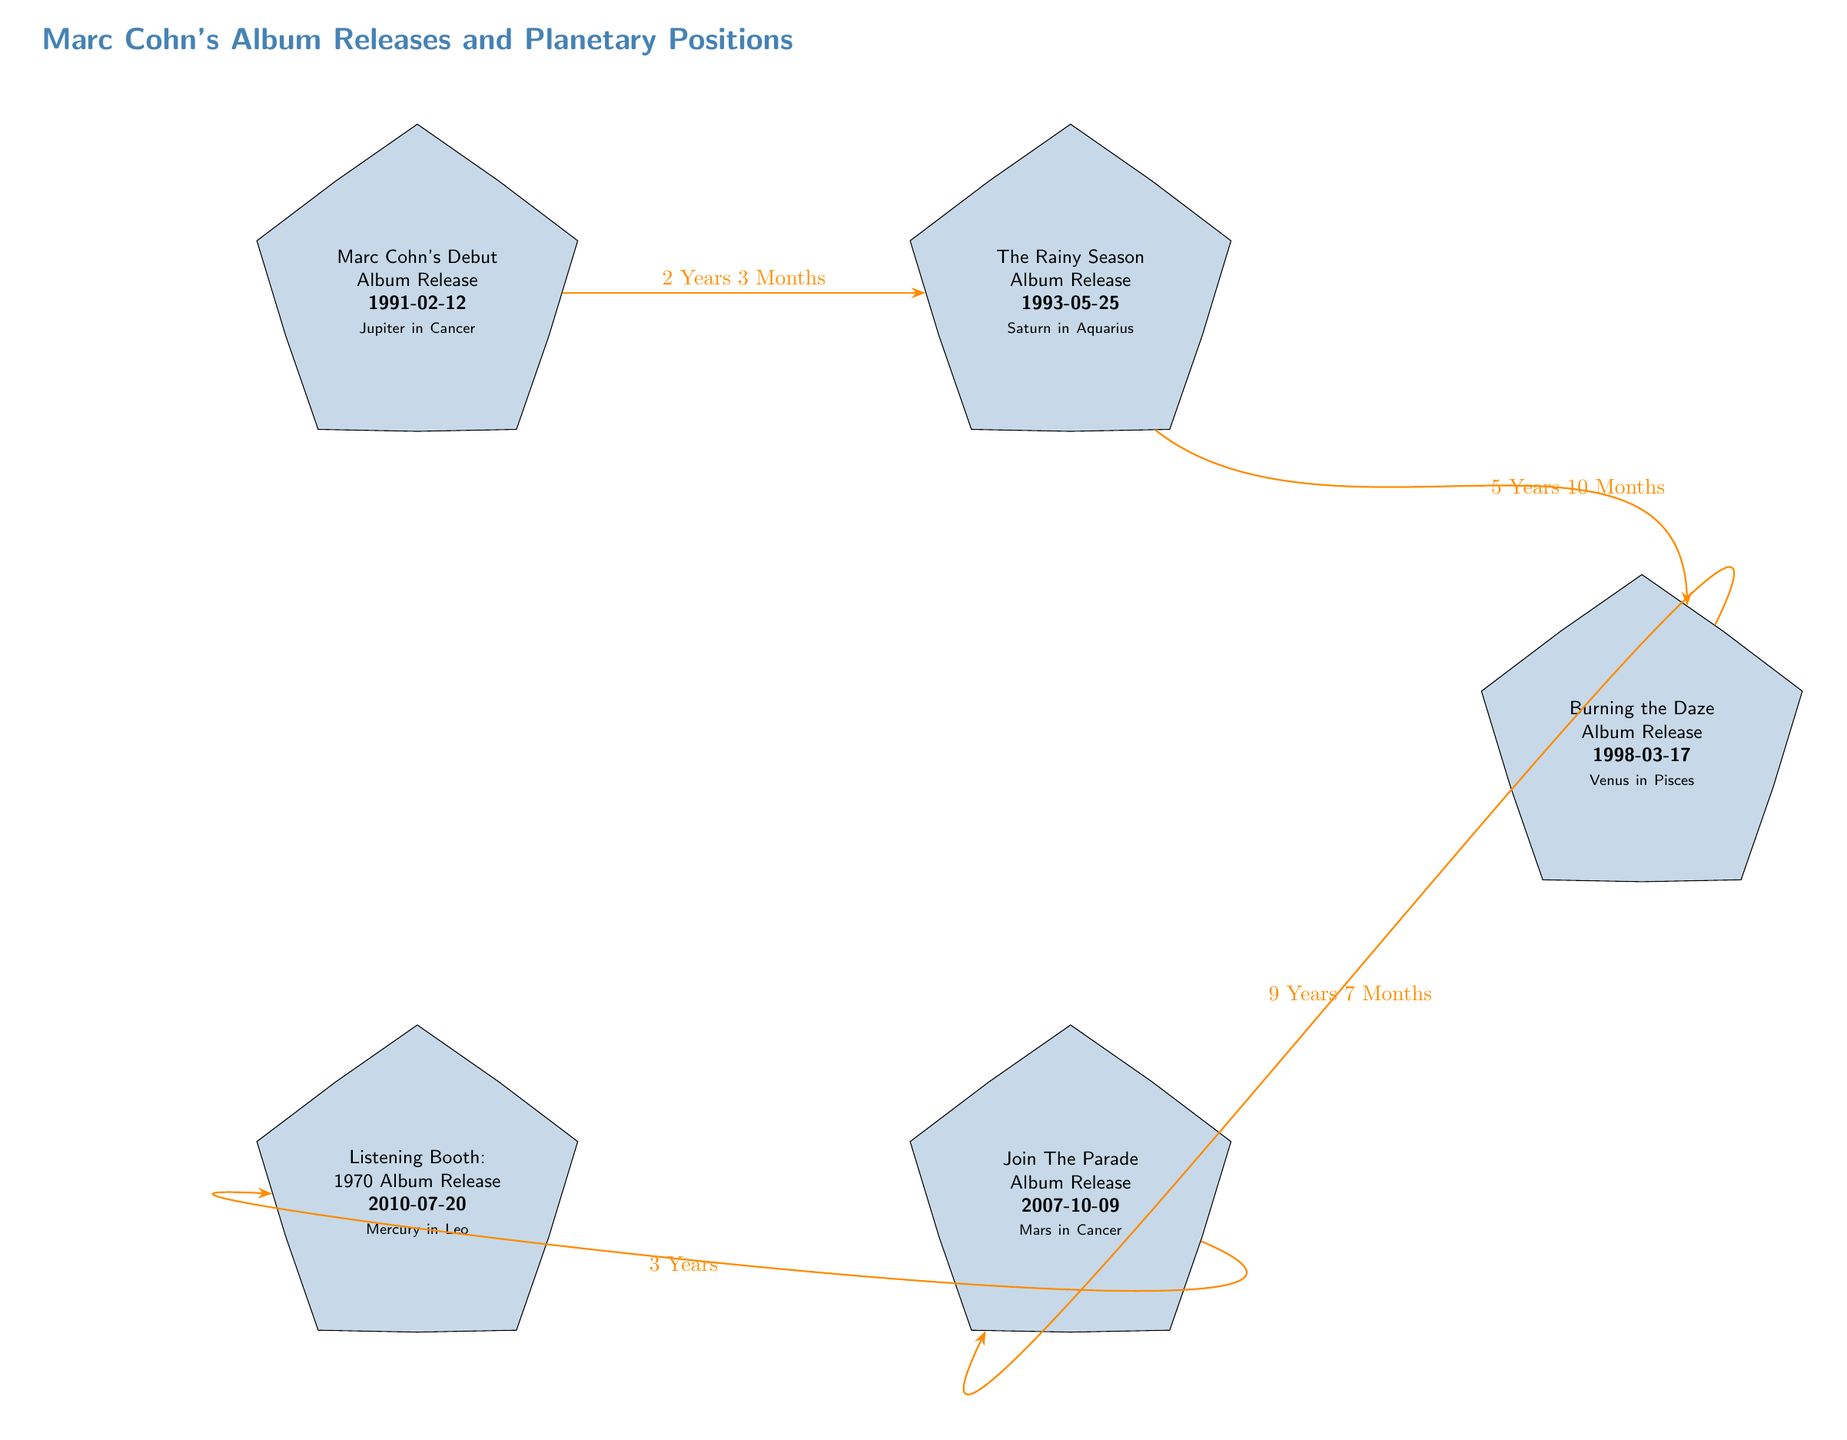What is the release date of Marc Cohn's debut album? The diagram shows that the release date of Marc Cohn's debut album is indicated in the first node as 1991-02-12.
Answer: 1991-02-12 Which album was released after "The Rainy Season"? The diagram has an edge connecting "The Rainy Season" to "Burning the Daze", indicating this is the next album in the timeline.
Answer: Burning the Daze How many years passed between the release of "Join The Parade" and "Listening Booth: 1970"? The edge between "Join The Parade" and "Listening Booth: 1970" is labeled with "3 Years", indicating the time elapsed between these two releases.
Answer: 3 Years What planetary position is associated with "Burning the Daze"? Referring to the node for "Burning the Daze", it specifies "Venus in Pisces" as the planetary position during its release.
Answer: Venus in Pisces Which album was released the longest after "The Rainy Season"? The diagram shows the edges between the album nodes, where "Burning the Daze" is 5 Years 10 Months after "The Rainy Season", while "Join The Parade" is 9 Years 7 Months. Therefore, "Join The Parade" is the longest after.
Answer: Join The Parade What is the relationship between "Marc Cohn's Debut Album" and "The Rainy Season"? The diagram provides an edge labeled "2 Years 3 Months" connecting these two nodes, indicating the time difference from the debut album to "The Rainy Season".
Answer: 2 Years 3 Months Which album released in 2010 features a planetary position in Leo? The node for "Listening Booth: 1970" specifies its release date as 2010-07-20 and notes "Mercury in Leo" as the planetary position.
Answer: Listening Booth: 1970 How many total albums are represented in the diagram? The diagram contains five nodes, each representing an album release by Marc Cohn.
Answer: 5 Which planet was in Aquarius during the release of "The Rainy Season"? The diagram notes that "The Rainy Season" has "Saturn in Aquarius" associated with its release.
Answer: Saturn 